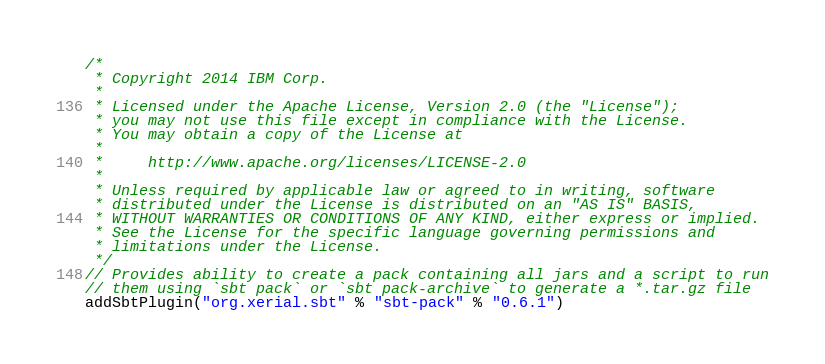Convert code to text. <code><loc_0><loc_0><loc_500><loc_500><_Scala_>/*
 * Copyright 2014 IBM Corp.
 *
 * Licensed under the Apache License, Version 2.0 (the "License");
 * you may not use this file except in compliance with the License.
 * You may obtain a copy of the License at
 *
 *     http://www.apache.org/licenses/LICENSE-2.0
 *
 * Unless required by applicable law or agreed to in writing, software
 * distributed under the License is distributed on an "AS IS" BASIS,
 * WITHOUT WARRANTIES OR CONDITIONS OF ANY KIND, either express or implied.
 * See the License for the specific language governing permissions and
 * limitations under the License.
 */
// Provides ability to create a pack containing all jars and a script to run
// them using `sbt pack` or `sbt pack-archive` to generate a *.tar.gz file
addSbtPlugin("org.xerial.sbt" % "sbt-pack" % "0.6.1")</code> 